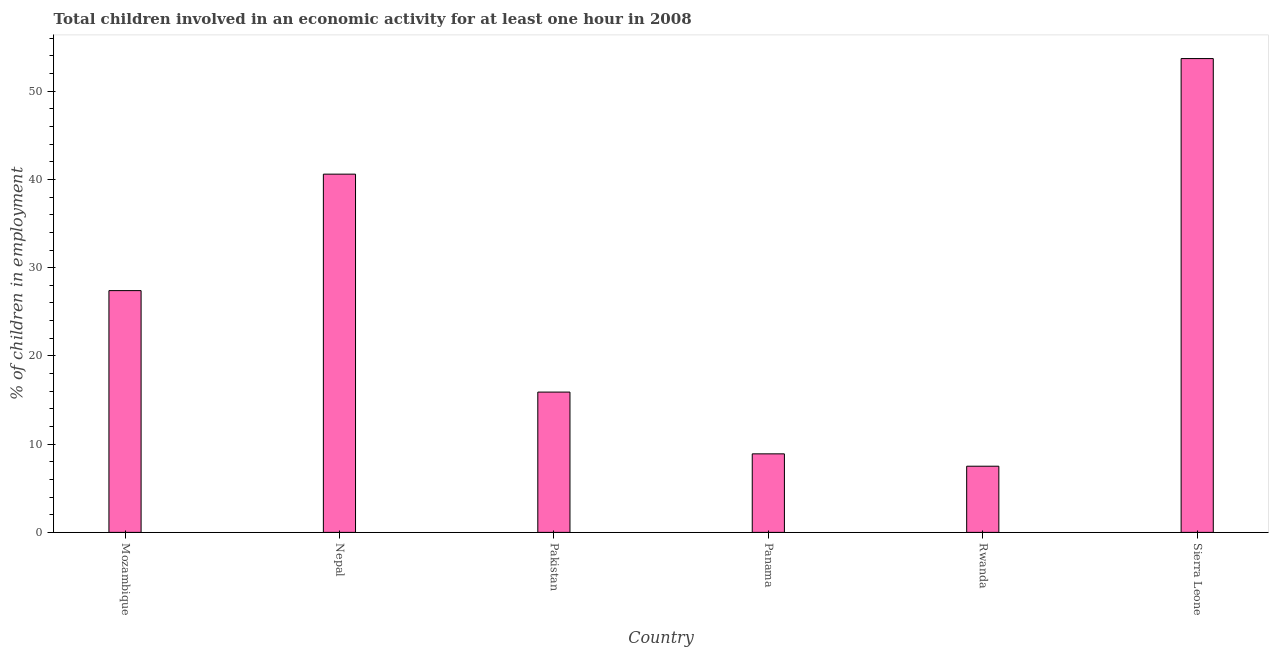Does the graph contain grids?
Keep it short and to the point. No. What is the title of the graph?
Provide a succinct answer. Total children involved in an economic activity for at least one hour in 2008. What is the label or title of the X-axis?
Give a very brief answer. Country. What is the label or title of the Y-axis?
Offer a very short reply. % of children in employment. What is the percentage of children in employment in Nepal?
Ensure brevity in your answer.  40.6. Across all countries, what is the maximum percentage of children in employment?
Make the answer very short. 53.7. Across all countries, what is the minimum percentage of children in employment?
Give a very brief answer. 7.5. In which country was the percentage of children in employment maximum?
Provide a succinct answer. Sierra Leone. In which country was the percentage of children in employment minimum?
Ensure brevity in your answer.  Rwanda. What is the sum of the percentage of children in employment?
Provide a succinct answer. 154. What is the average percentage of children in employment per country?
Give a very brief answer. 25.67. What is the median percentage of children in employment?
Your answer should be compact. 21.65. In how many countries, is the percentage of children in employment greater than 44 %?
Give a very brief answer. 1. What is the ratio of the percentage of children in employment in Pakistan to that in Sierra Leone?
Offer a very short reply. 0.3. Is the percentage of children in employment in Panama less than that in Rwanda?
Your response must be concise. No. Is the difference between the percentage of children in employment in Mozambique and Pakistan greater than the difference between any two countries?
Ensure brevity in your answer.  No. What is the difference between the highest and the second highest percentage of children in employment?
Offer a very short reply. 13.1. What is the difference between the highest and the lowest percentage of children in employment?
Give a very brief answer. 46.2. In how many countries, is the percentage of children in employment greater than the average percentage of children in employment taken over all countries?
Offer a terse response. 3. Are all the bars in the graph horizontal?
Your answer should be very brief. No. What is the % of children in employment in Mozambique?
Provide a short and direct response. 27.4. What is the % of children in employment in Nepal?
Provide a short and direct response. 40.6. What is the % of children in employment in Pakistan?
Give a very brief answer. 15.9. What is the % of children in employment of Sierra Leone?
Ensure brevity in your answer.  53.7. What is the difference between the % of children in employment in Mozambique and Pakistan?
Keep it short and to the point. 11.5. What is the difference between the % of children in employment in Mozambique and Panama?
Your answer should be compact. 18.5. What is the difference between the % of children in employment in Mozambique and Rwanda?
Your answer should be compact. 19.9. What is the difference between the % of children in employment in Mozambique and Sierra Leone?
Ensure brevity in your answer.  -26.3. What is the difference between the % of children in employment in Nepal and Pakistan?
Your answer should be very brief. 24.7. What is the difference between the % of children in employment in Nepal and Panama?
Give a very brief answer. 31.7. What is the difference between the % of children in employment in Nepal and Rwanda?
Offer a terse response. 33.1. What is the difference between the % of children in employment in Nepal and Sierra Leone?
Your answer should be compact. -13.1. What is the difference between the % of children in employment in Pakistan and Rwanda?
Offer a very short reply. 8.4. What is the difference between the % of children in employment in Pakistan and Sierra Leone?
Ensure brevity in your answer.  -37.8. What is the difference between the % of children in employment in Panama and Rwanda?
Offer a terse response. 1.4. What is the difference between the % of children in employment in Panama and Sierra Leone?
Ensure brevity in your answer.  -44.8. What is the difference between the % of children in employment in Rwanda and Sierra Leone?
Give a very brief answer. -46.2. What is the ratio of the % of children in employment in Mozambique to that in Nepal?
Provide a short and direct response. 0.68. What is the ratio of the % of children in employment in Mozambique to that in Pakistan?
Offer a very short reply. 1.72. What is the ratio of the % of children in employment in Mozambique to that in Panama?
Keep it short and to the point. 3.08. What is the ratio of the % of children in employment in Mozambique to that in Rwanda?
Keep it short and to the point. 3.65. What is the ratio of the % of children in employment in Mozambique to that in Sierra Leone?
Your response must be concise. 0.51. What is the ratio of the % of children in employment in Nepal to that in Pakistan?
Keep it short and to the point. 2.55. What is the ratio of the % of children in employment in Nepal to that in Panama?
Provide a succinct answer. 4.56. What is the ratio of the % of children in employment in Nepal to that in Rwanda?
Offer a very short reply. 5.41. What is the ratio of the % of children in employment in Nepal to that in Sierra Leone?
Keep it short and to the point. 0.76. What is the ratio of the % of children in employment in Pakistan to that in Panama?
Offer a very short reply. 1.79. What is the ratio of the % of children in employment in Pakistan to that in Rwanda?
Your response must be concise. 2.12. What is the ratio of the % of children in employment in Pakistan to that in Sierra Leone?
Keep it short and to the point. 0.3. What is the ratio of the % of children in employment in Panama to that in Rwanda?
Keep it short and to the point. 1.19. What is the ratio of the % of children in employment in Panama to that in Sierra Leone?
Provide a short and direct response. 0.17. What is the ratio of the % of children in employment in Rwanda to that in Sierra Leone?
Keep it short and to the point. 0.14. 